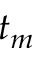Convert formula to latex. <formula><loc_0><loc_0><loc_500><loc_500>t _ { m }</formula> 